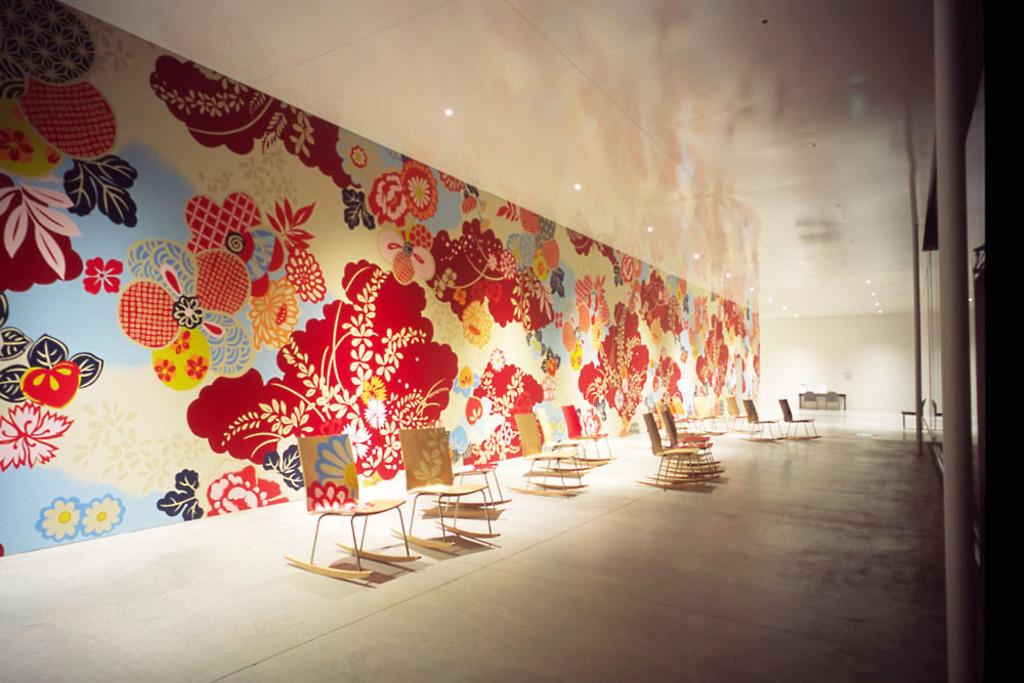What type of furniture is located in the middle of the image? There are chairs in the middle of the image. What can be seen on the wall in the background of the image? There are paintings on the wall in the background of the image. What type of lighting is visible at the top of the image? There are ceiling lights visible at the top of the image. How many planes are flying over the edge of the image? There are no planes visible in the image, and the concept of an "edge" is not applicable to a two-dimensional image. 